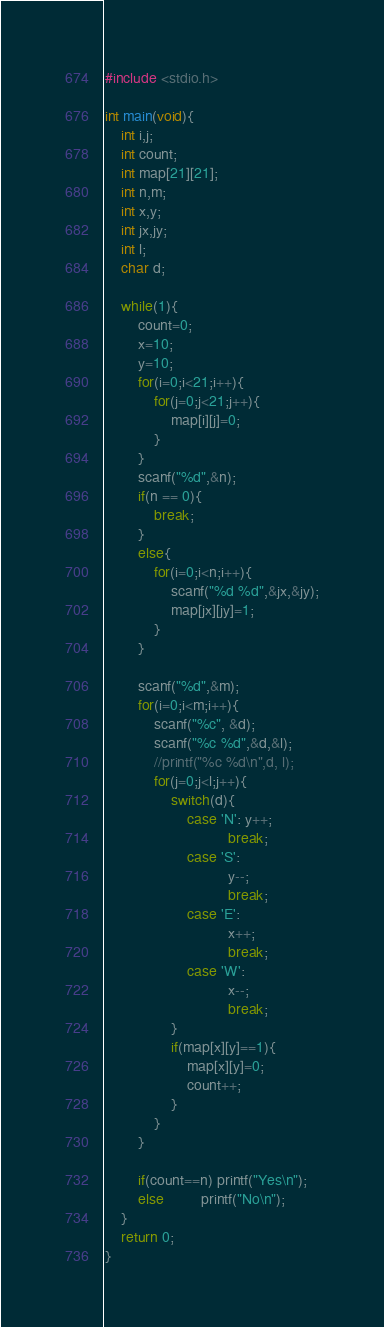Convert code to text. <code><loc_0><loc_0><loc_500><loc_500><_C_>#include <stdio.h>

int main(void){
	int i,j;
	int count;
	int map[21][21];
	int n,m;
	int x,y;
	int jx,jy;
	int l;
	char d;
		
	while(1){
		count=0;
		x=10;
		y=10;
		for(i=0;i<21;i++){
			for(j=0;j<21;j++){
				map[i][j]=0;
			}
		}
		scanf("%d",&n);
		if(n == 0){
			break;
		}
		else{
			for(i=0;i<n;i++){
				scanf("%d %d",&jx,&jy);
				map[jx][jy]=1;
			}
		}
		
		scanf("%d",&m);
		for(i=0;i<m;i++){
			scanf("%c", &d);
			scanf("%c %d",&d,&l);
			//printf("%c %d\n",d, l);
			for(j=0;j<l;j++){
				switch(d){
					case 'N': y++;
							  break;
					case 'S':
							  y--;
							  break;
					case 'E':
							  x++;
							  break;
					case 'W':
							  x--;
							  break;
				}
				if(map[x][y]==1){
					map[x][y]=0;
					count++;
				}
			}
		}
		
		if(count==n) printf("Yes\n");
		else		 printf("No\n");
	}
	return 0;
}</code> 